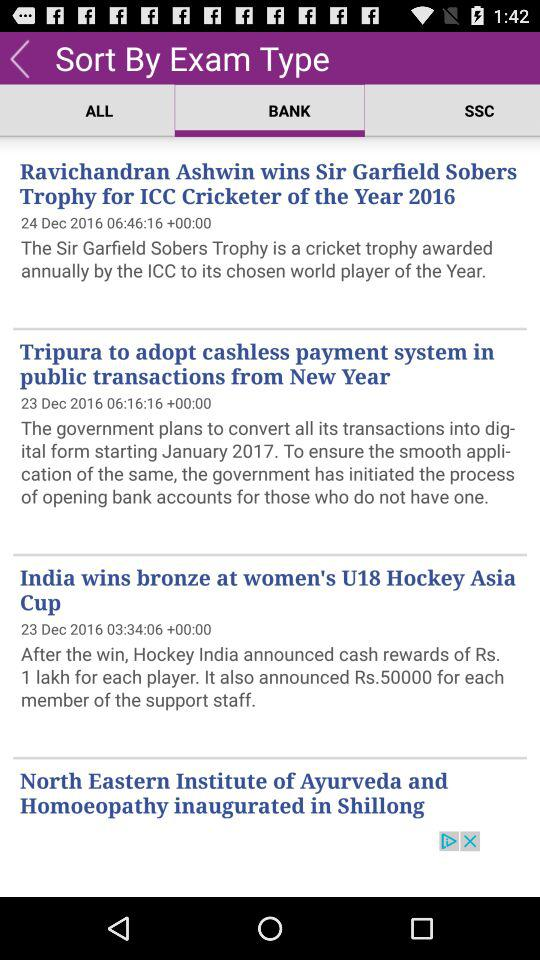How many more days have passed since the most recent news item than the oldest news item?
Answer the question using a single word or phrase. 1 